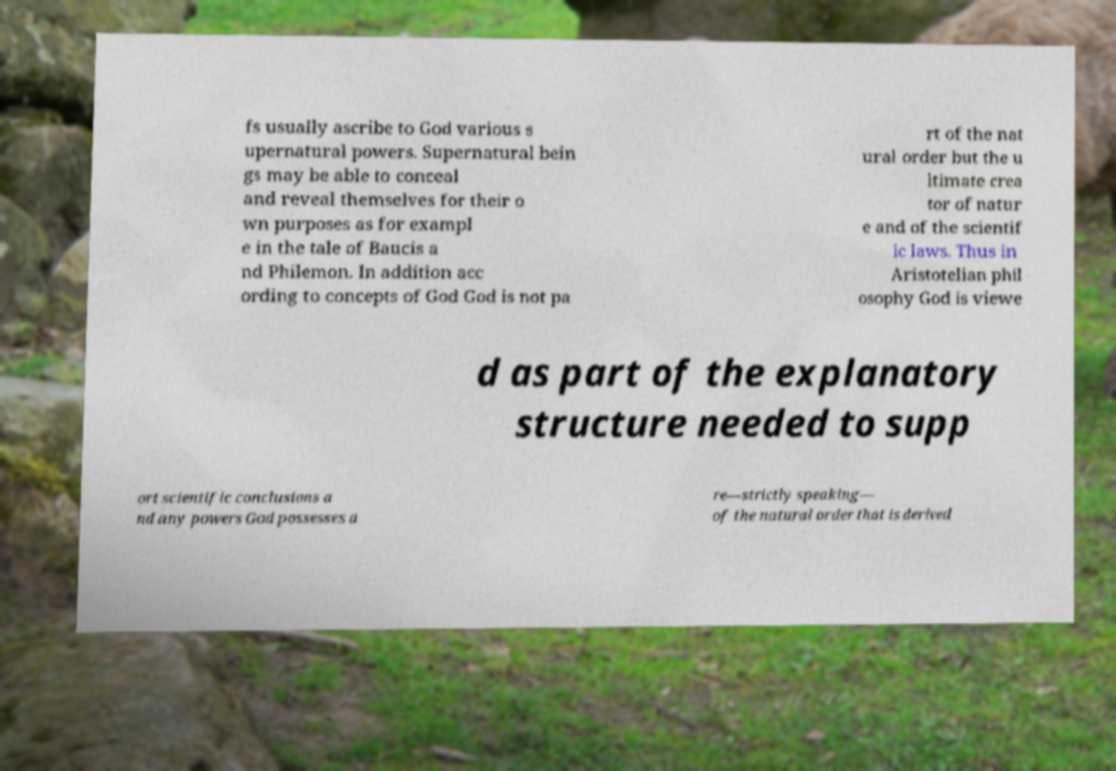There's text embedded in this image that I need extracted. Can you transcribe it verbatim? fs usually ascribe to God various s upernatural powers. Supernatural bein gs may be able to conceal and reveal themselves for their o wn purposes as for exampl e in the tale of Baucis a nd Philemon. In addition acc ording to concepts of God God is not pa rt of the nat ural order but the u ltimate crea tor of natur e and of the scientif ic laws. Thus in Aristotelian phil osophy God is viewe d as part of the explanatory structure needed to supp ort scientific conclusions a nd any powers God possesses a re—strictly speaking— of the natural order that is derived 